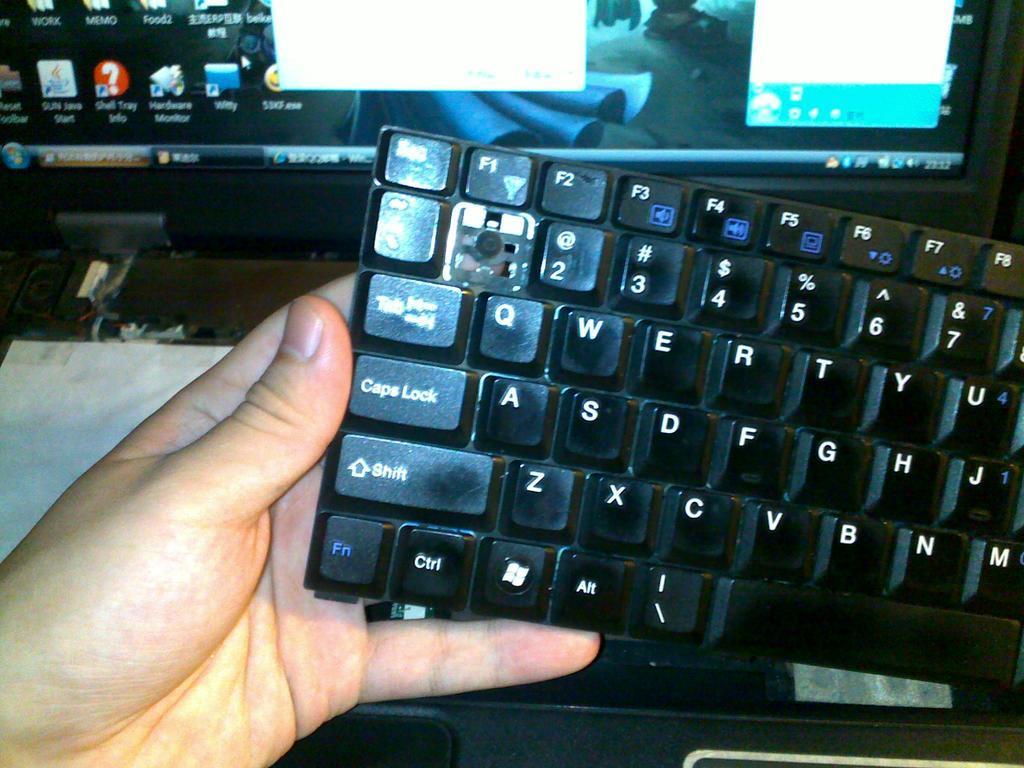Please provide a concise description of this image. In this picture we can see the person hand holding the black keyboard. Behind there is a computer screen. 